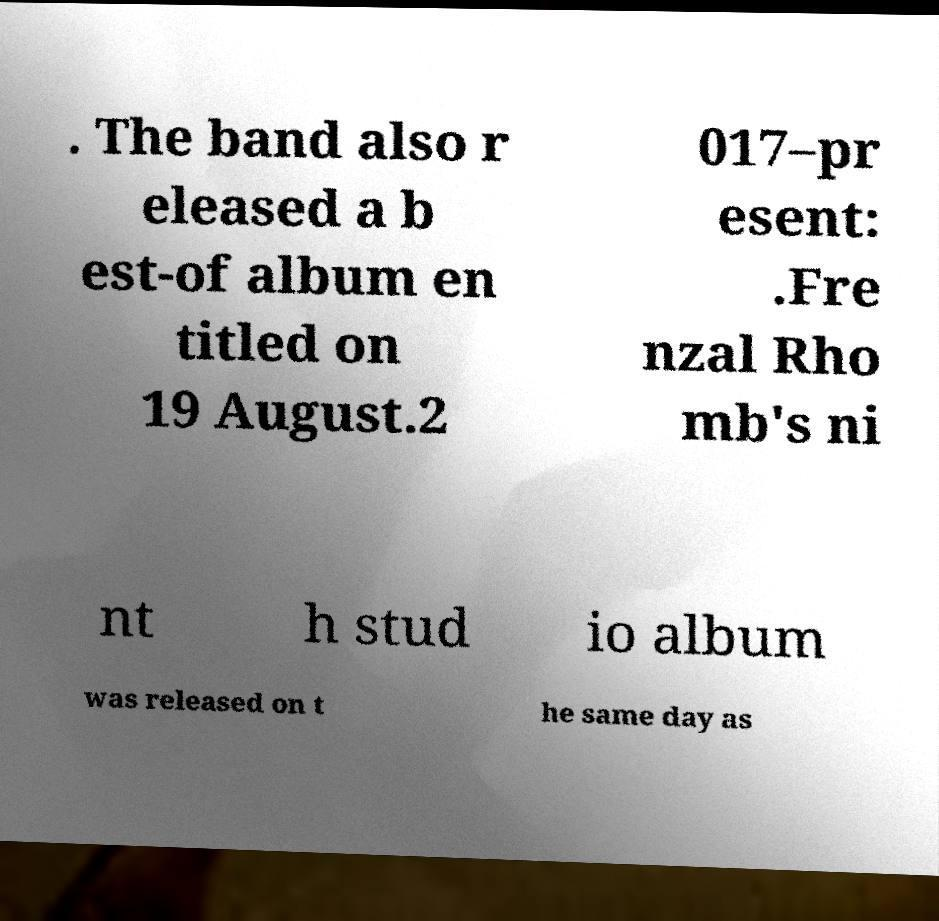Please read and relay the text visible in this image. What does it say? . The band also r eleased a b est-of album en titled on 19 August.2 017–pr esent: .Fre nzal Rho mb's ni nt h stud io album was released on t he same day as 